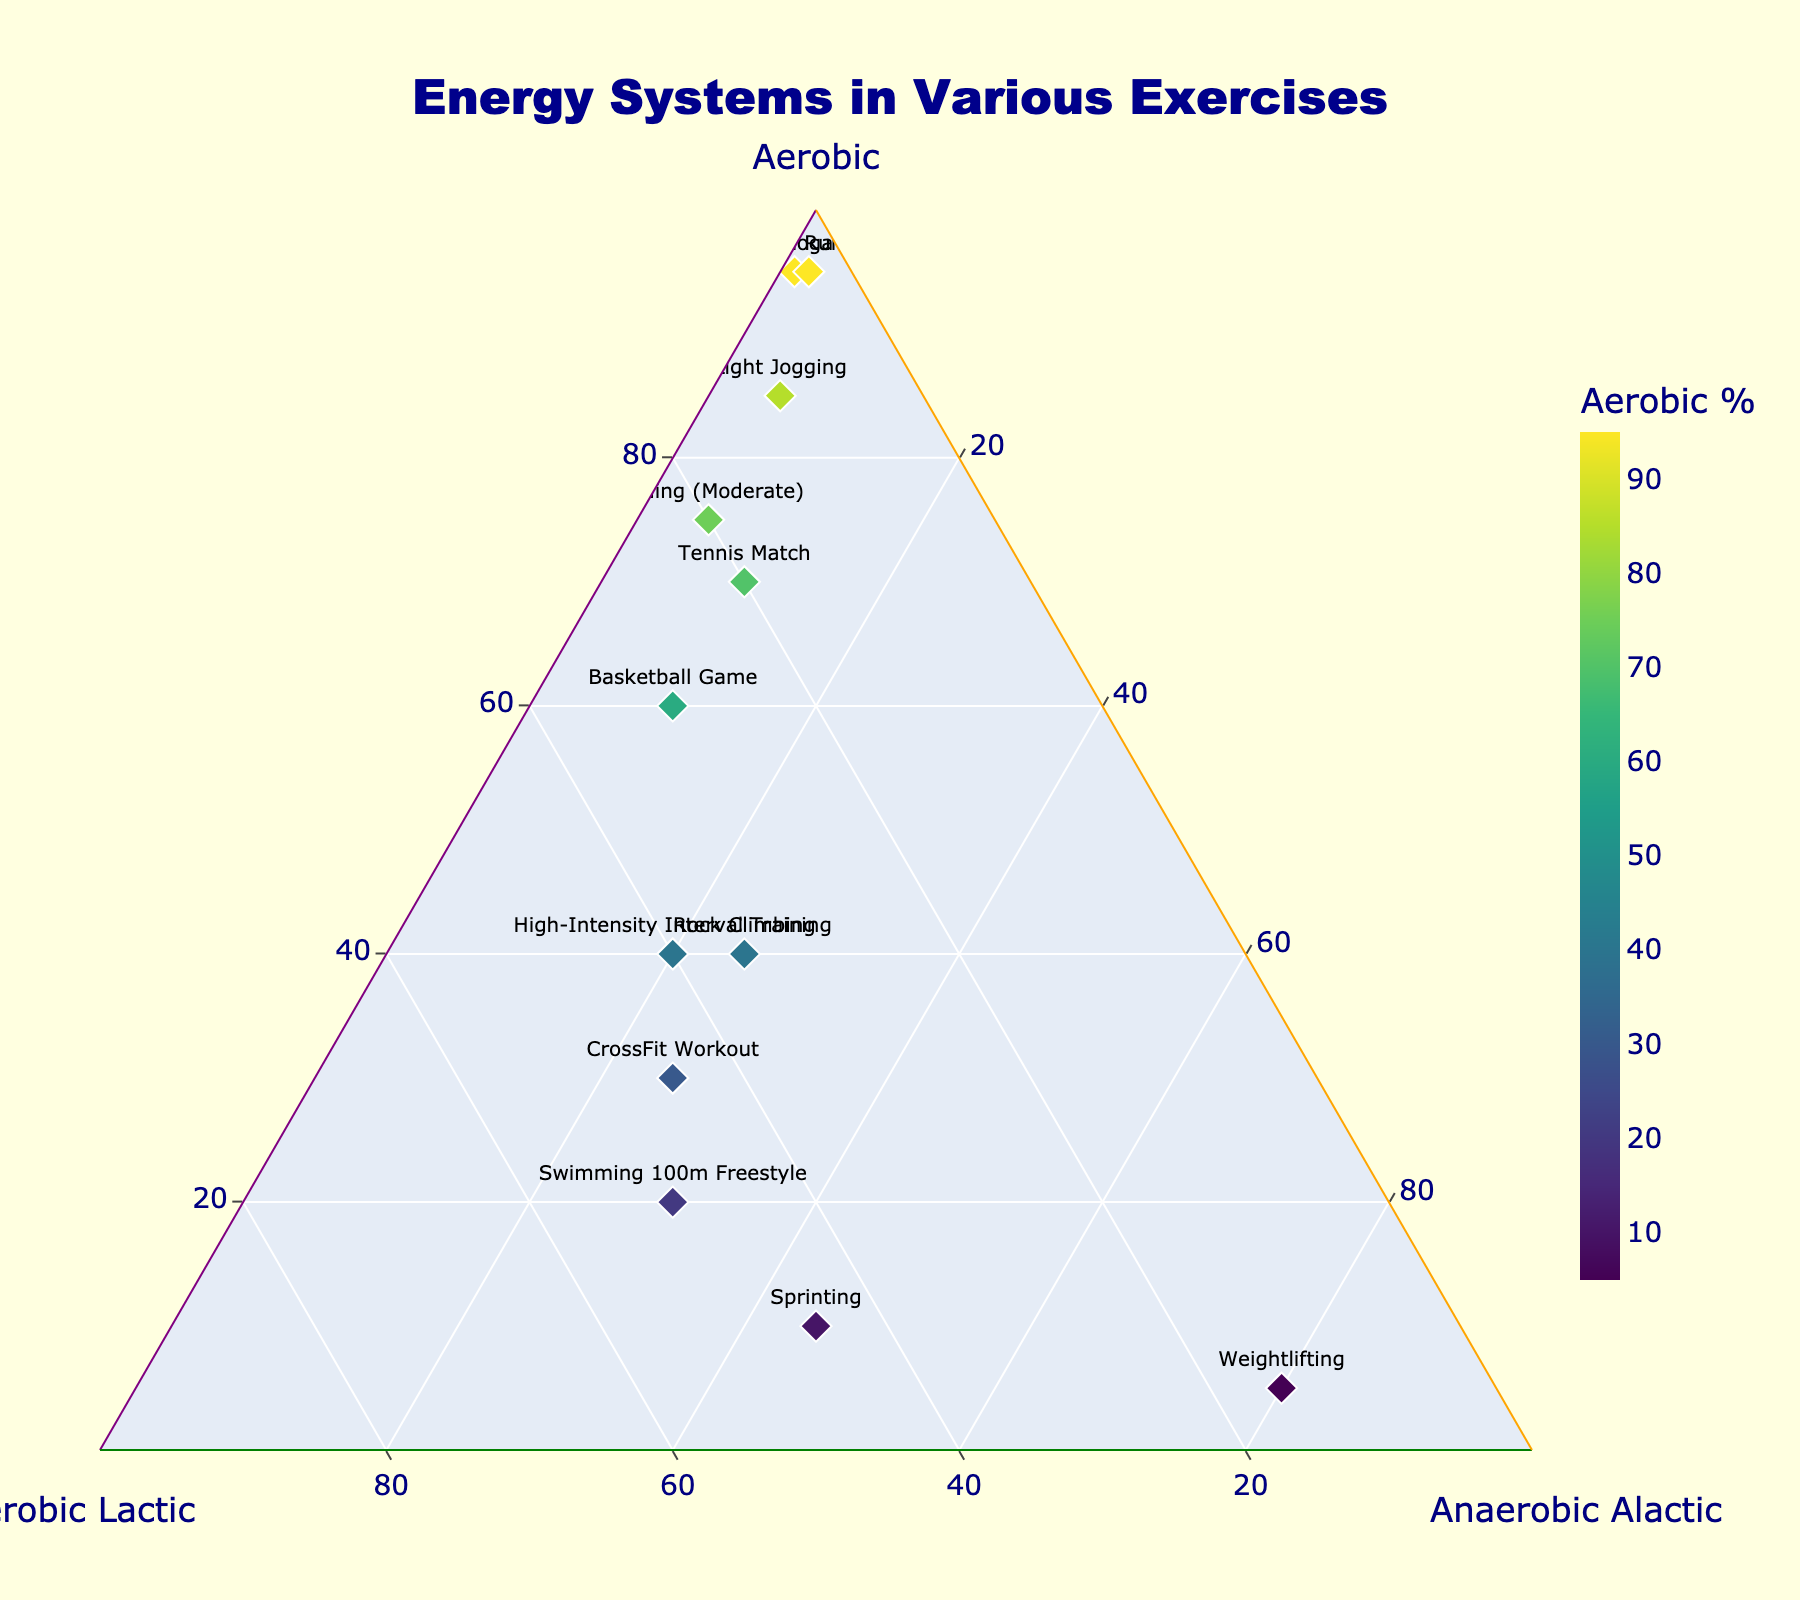What is the title of the plot? The title of the plot is usually positioned at the top center of the figure. In this case, it reads 'Energy Systems in Various Exercises'.
Answer: Energy Systems in Various Exercises Which exercise utilizes the highest percentage of the aerobic system? To find the exercise with the highest aerobic percentage, look for the data point with the highest value on the Aerobic axis. Marathon Running has 95% aerobic usage, making it the highest.
Answer: Marathon Running How many exercises have more than 40% aerobic and more than 20% anaerobic lactic energy usage? Identify the data points that meet both criteria: more than 40% aerobic and more than 20% anaerobic lactic. The exercises are High-Intensity Interval Training (40%, 40%) and Rock Climbing (40%, 35%). Thus, there are 2 exercises.
Answer: 2 Which exercise relies most heavily on the anaerobic alactic system? The exercise that relies most on the anaerobic alactic system is the one with the highest value on the Anaerobic Alactic axis. Weightlifting has 80% anaerobic alactic usage, making it the highest.
Answer: Weightlifting Compare the anaerobic lactic percentage of Sprinting and Swimming 100m Freestyle. Which one has a higher value? Look at the data points for Sprinting and Swimming 100m Freestyle on the Anaerobic Lactic axis. Sprinting has 45% and Swimming 100m Freestyle has 50%. Therefore, Swimming 100m Freestyle has a higher value.
Answer: Swimming 100m Freestyle What is the combined percentage of aerobic and anaerobic lactic energy usage in a Tennis Match? To find the combined percentage, add the aerobic and anaerobic lactic values for Tennis Match. It's 70% aerobic + 20% anaerobic lactic = 90%.
Answer: 90% Does any exercise have exactly equal usage of all three energy systems? Check all data points to see if there is any exercise where the percentages of Aerobic, Anaerobic Lactic, and Anaerobic Alactic are all equal. None of the exercises in this dataset have equal usage of all three systems.
Answer: No Which exercises use less than 10% anaerobic lactic energy? Find the exercises with anaerobic lactic energy usage below 10%. These are Marathon Running (4%) and Yoga (3%).
Answer: Marathon Running, Yoga Which exercise has a more balanced use of the three energy systems, High-Intensity Interval Training or CrossFit Workout? Examine the data for both exercises. High-Intensity Interval Training has 40% aerobic, 40% anaerobic lactic, and 20% anaerobic alactic. CrossFit Workout has 30% aerobic, 45% anaerobic lactic, and 25% anaerobic alactic. High-Intensity Interval Training has more balanced values.
Answer: High-Intensity Interval Training 